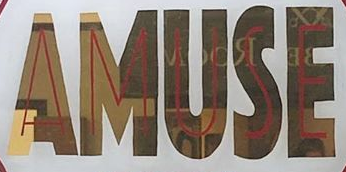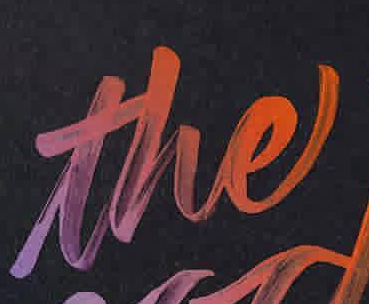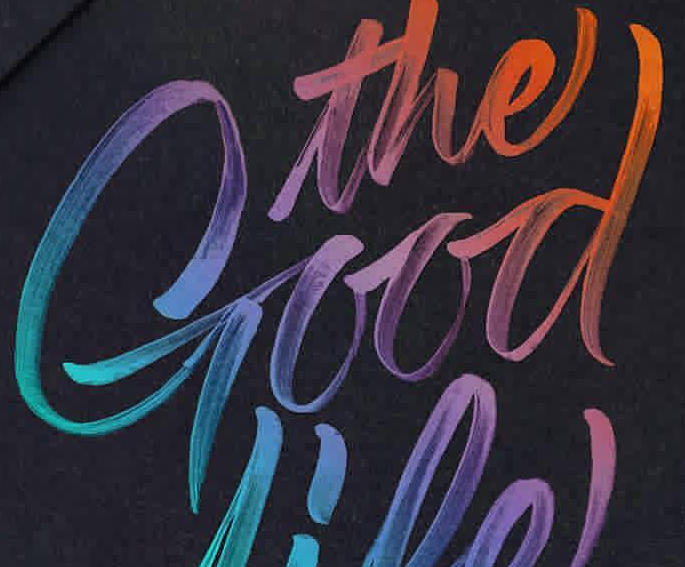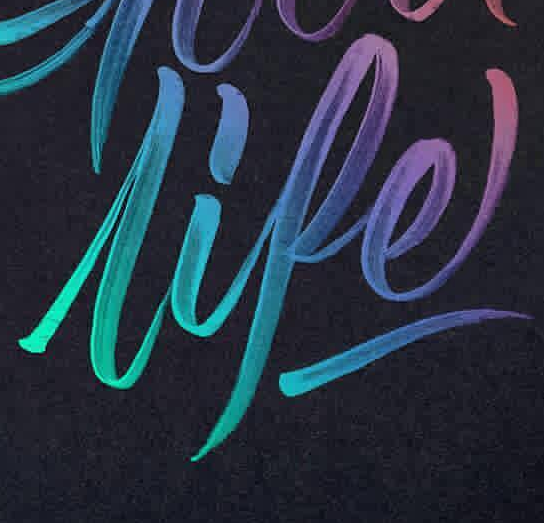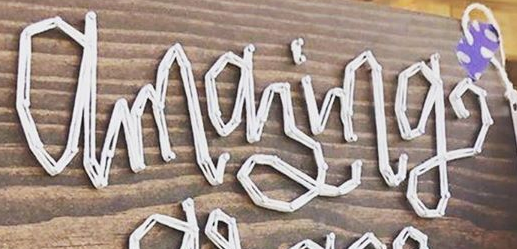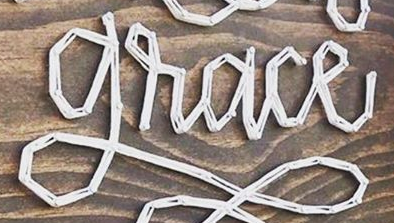Read the text from these images in sequence, separated by a semicolon. AMUSE; the; Good; lipe; amazing; grace 